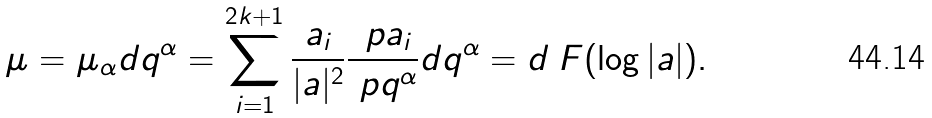Convert formula to latex. <formula><loc_0><loc_0><loc_500><loc_500>\mu = \mu _ { \alpha } d q ^ { \alpha } = \sum _ { i = 1 } ^ { 2 k + 1 } \frac { a _ { i } } { | a | ^ { 2 } } \frac { \ p a _ { i } } { \ p q ^ { \alpha } } d q ^ { \alpha } = d _ { \ } F ( \log | a | ) .</formula> 